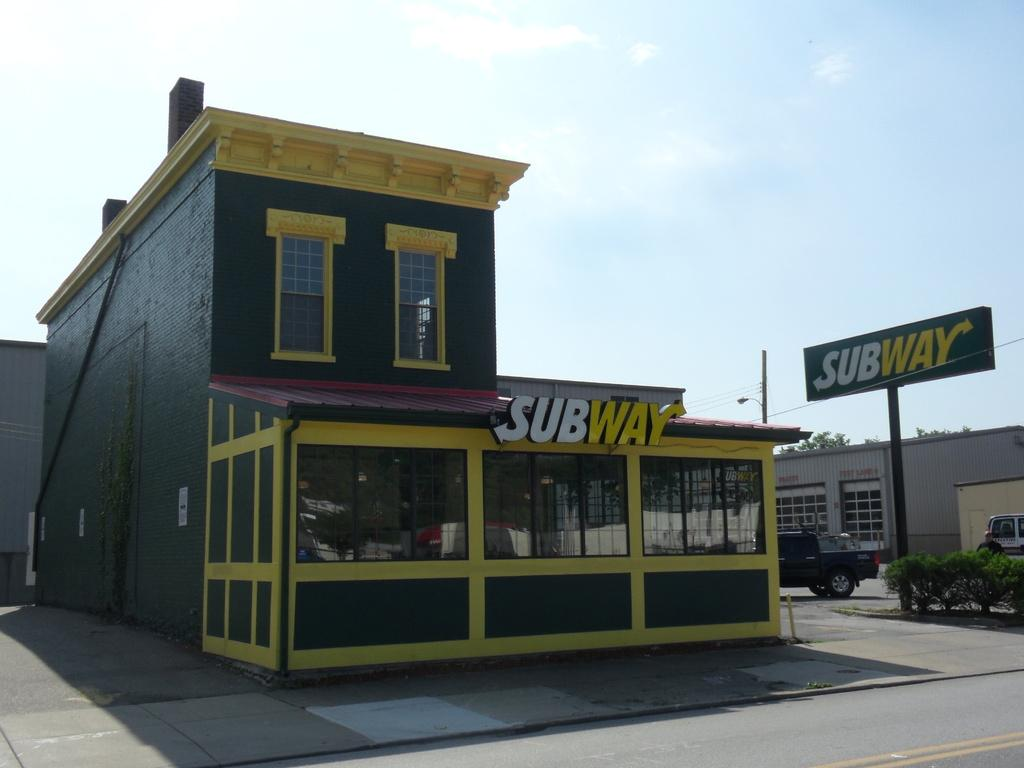What type of structures can be seen in the image? There are buildings in the image. What type of advertisements are present in the image? There are hoardings in the image. What type of vegetation is present in the image? There are shrubs and trees in the image. What type of vertical structure is present in the image? There is a pole in the image. What type of transportation is present in the image? There are vehicles in the image. What type of star can be seen in the image? There is no star present in the image. What type of washing machine is visible in the image? There is no washing machine present in the image. 